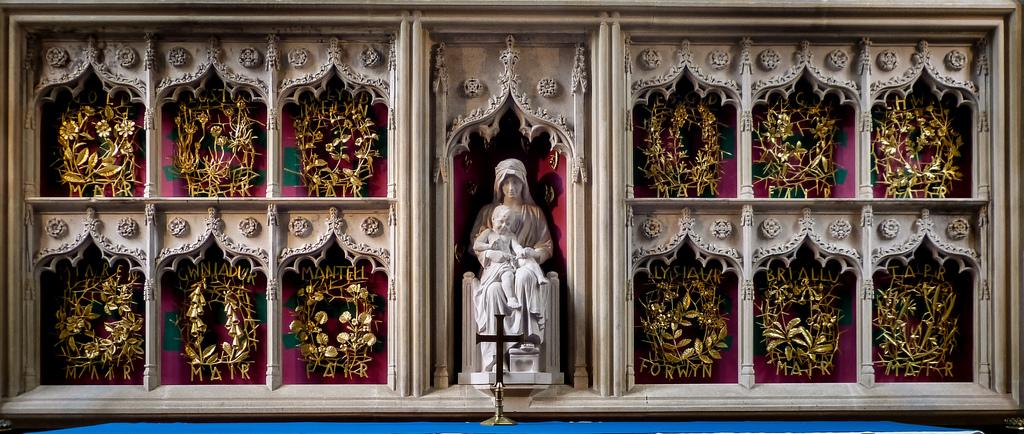What can be seen in the foreground of the image? In the foreground, there are two persons depicted as statues, shelves, and rods. What might be the setting of the image? The image may have been taken in a church. What type of plastic material can be seen in the image? There is no plastic material present in the image. What role does the mother play in the image? There is no mention of a mother or any person's role in the image; it features statues and objects in a possible church setting. 